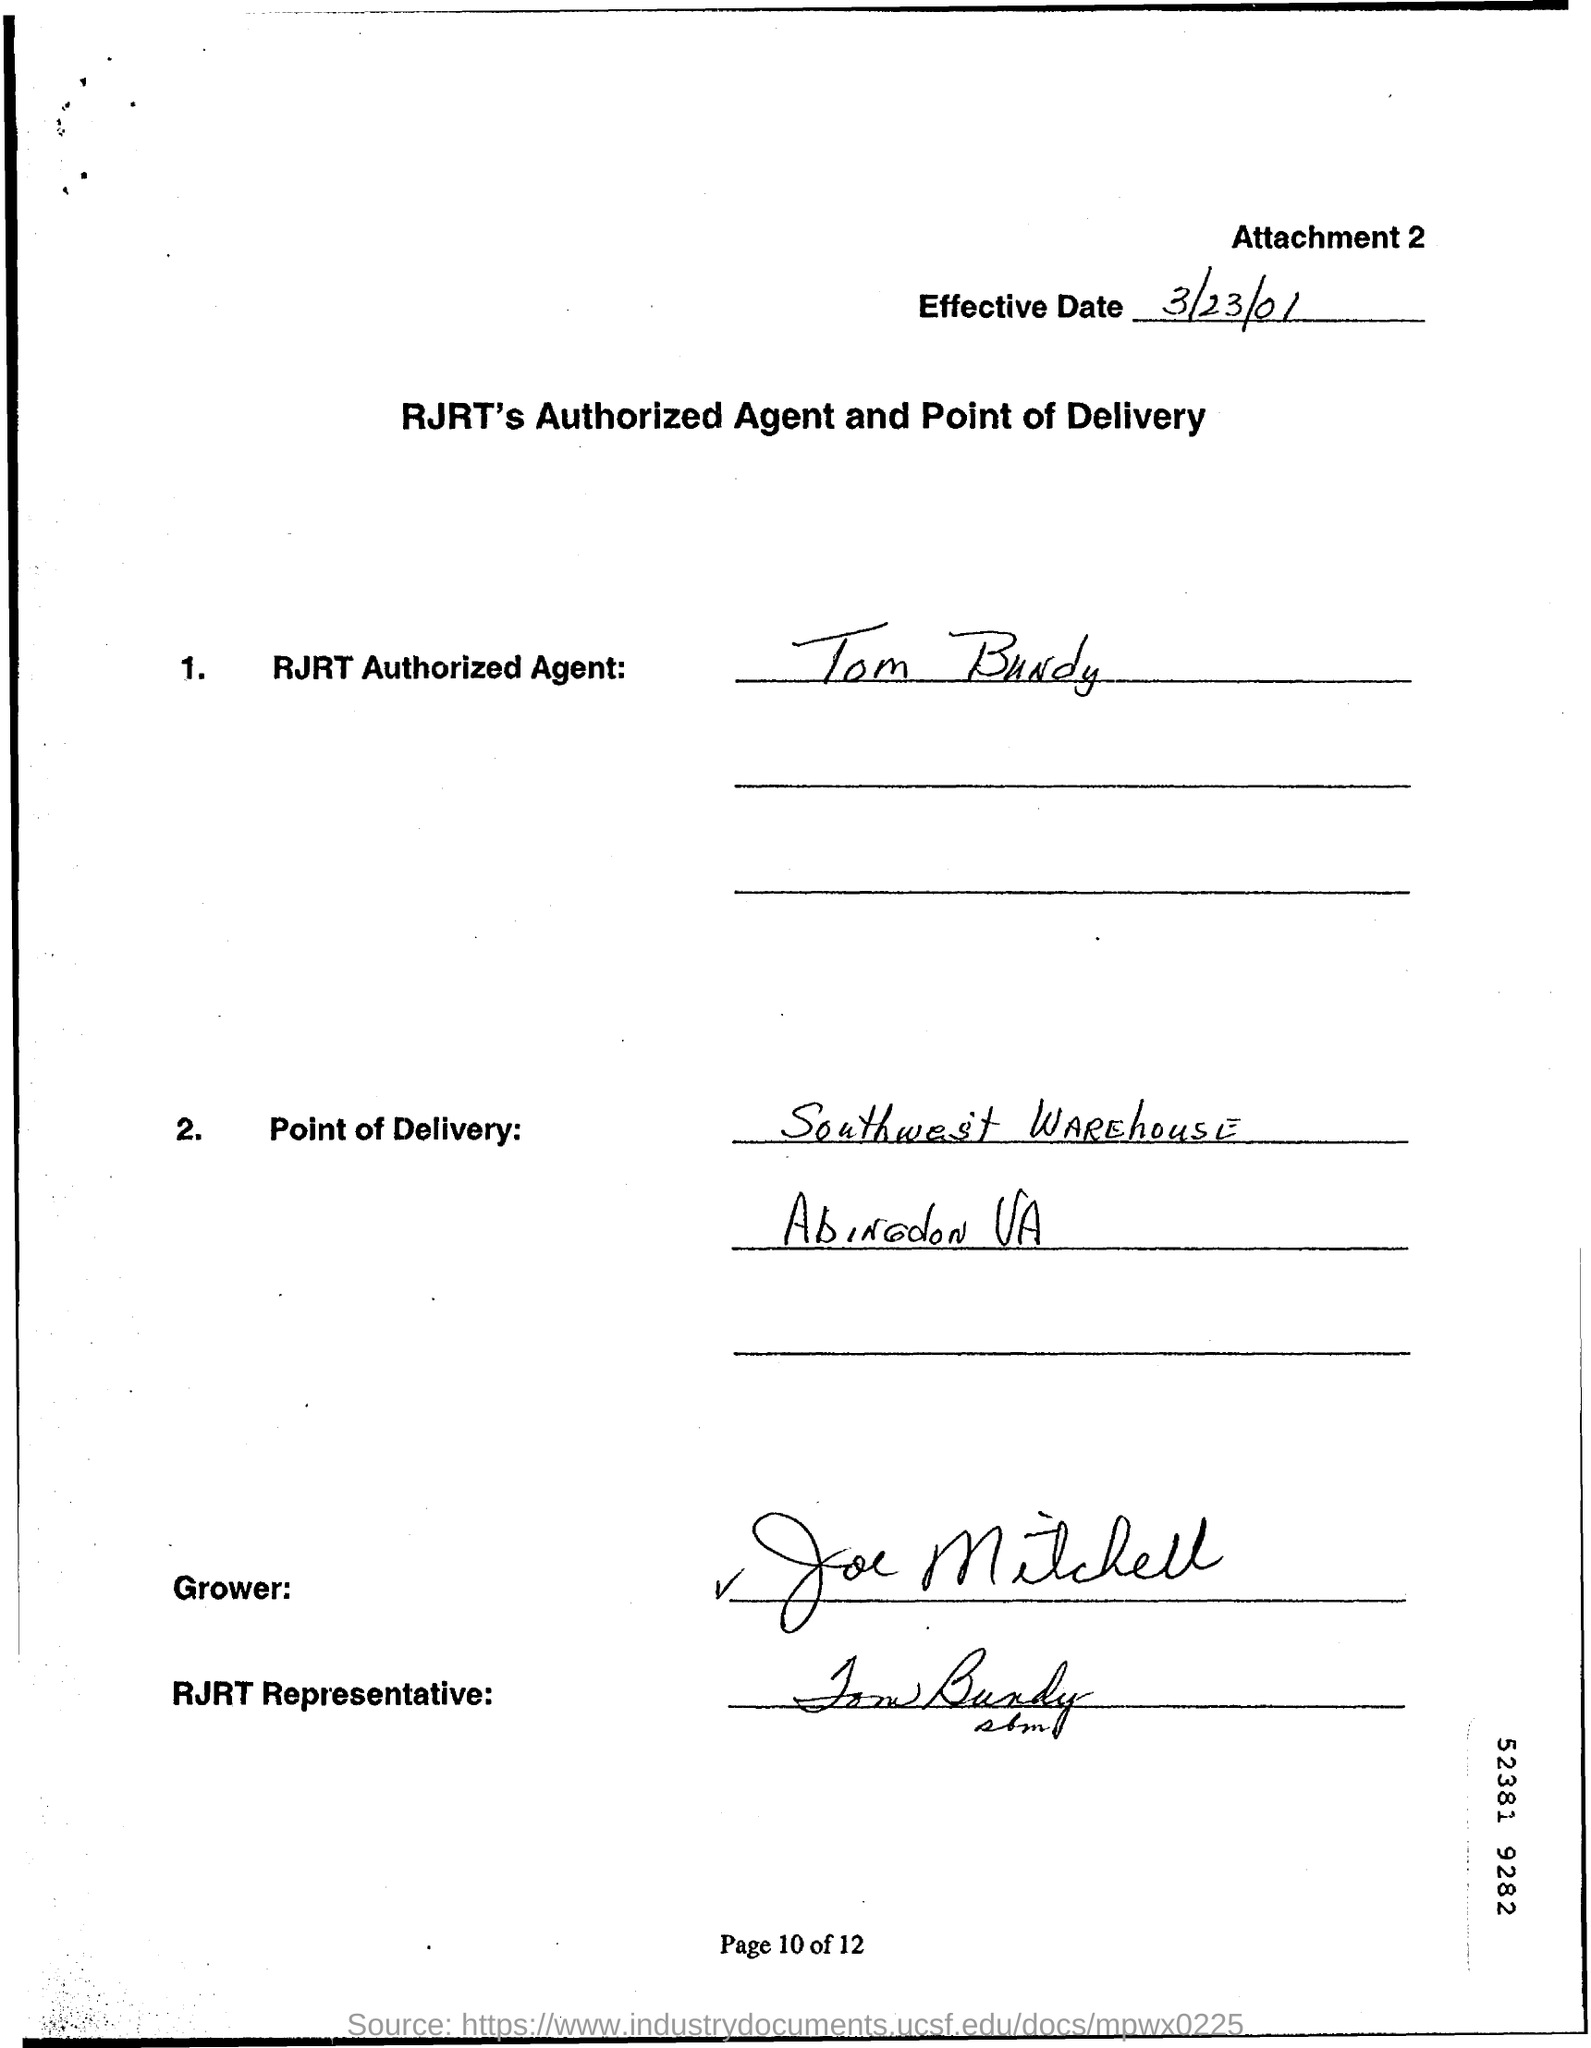Highlight a few significant elements in this photo. The location of the delivery is Southwest Warehouse in Abingdon, Virginia. The RJRT Authorized Agent is Tom Bundy. The effective date of March 23, 2001, is the date upon which the specified action or event will take place. 